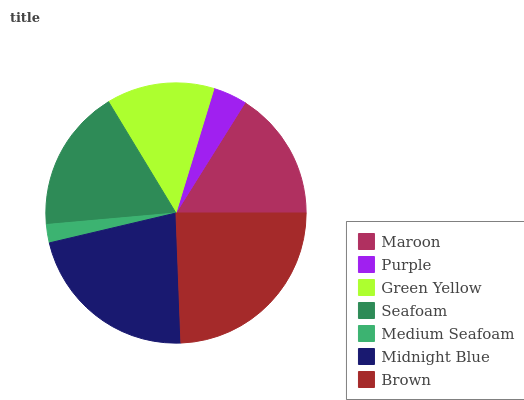Is Medium Seafoam the minimum?
Answer yes or no. Yes. Is Brown the maximum?
Answer yes or no. Yes. Is Purple the minimum?
Answer yes or no. No. Is Purple the maximum?
Answer yes or no. No. Is Maroon greater than Purple?
Answer yes or no. Yes. Is Purple less than Maroon?
Answer yes or no. Yes. Is Purple greater than Maroon?
Answer yes or no. No. Is Maroon less than Purple?
Answer yes or no. No. Is Maroon the high median?
Answer yes or no. Yes. Is Maroon the low median?
Answer yes or no. Yes. Is Seafoam the high median?
Answer yes or no. No. Is Brown the low median?
Answer yes or no. No. 